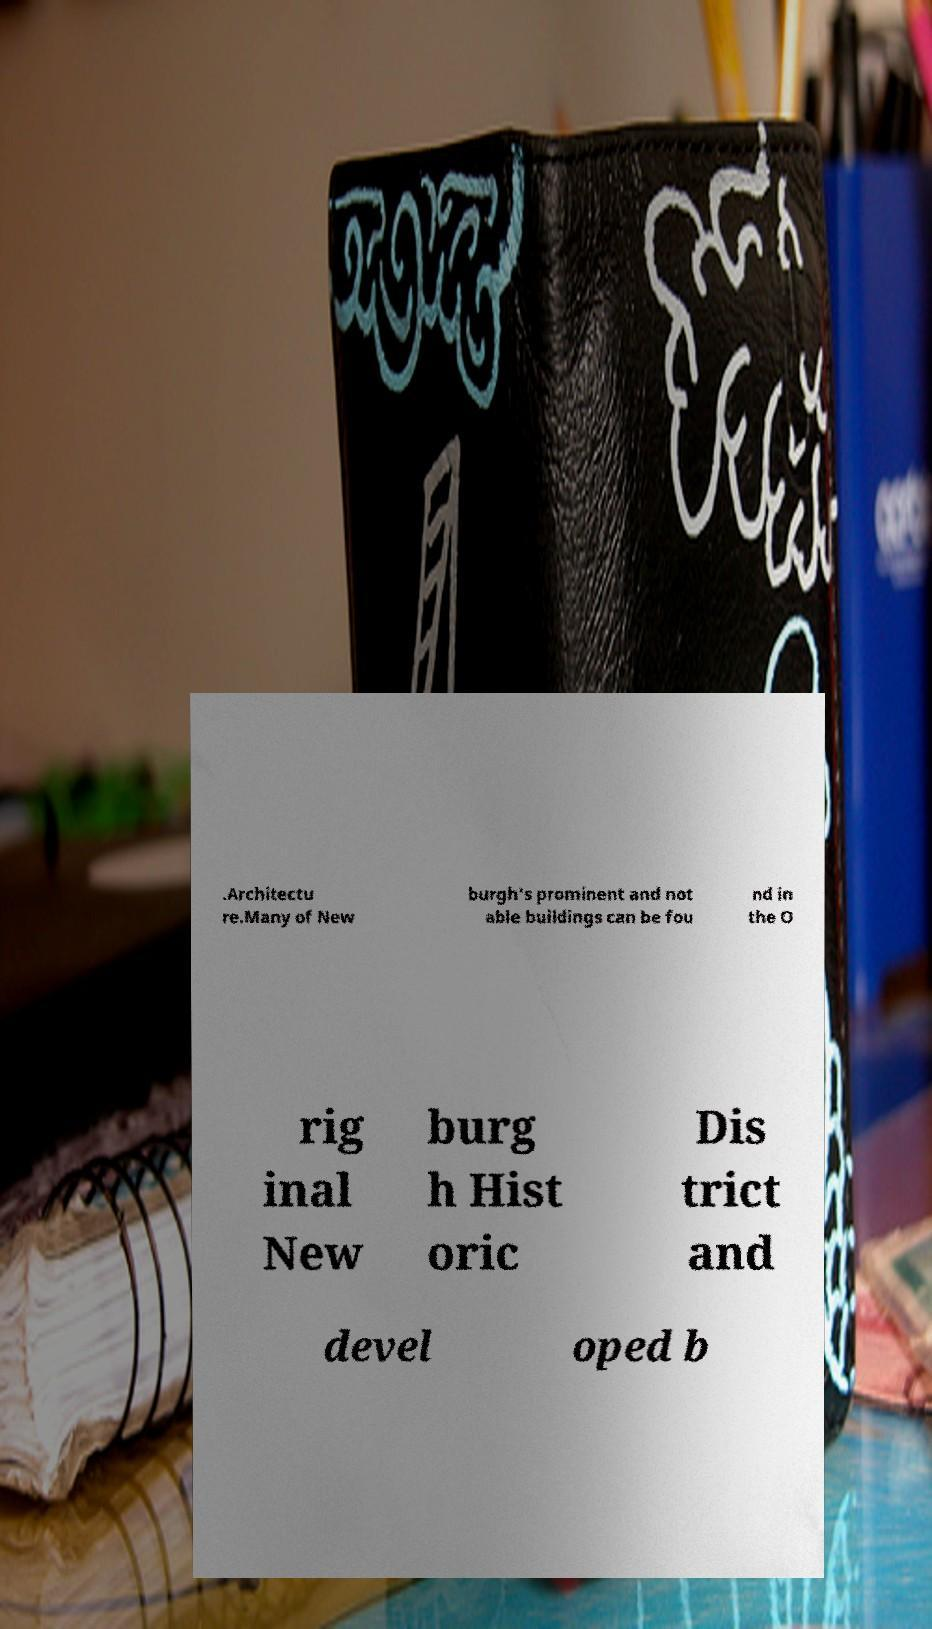Please read and relay the text visible in this image. What does it say? .Architectu re.Many of New burgh's prominent and not able buildings can be fou nd in the O rig inal New burg h Hist oric Dis trict and devel oped b 